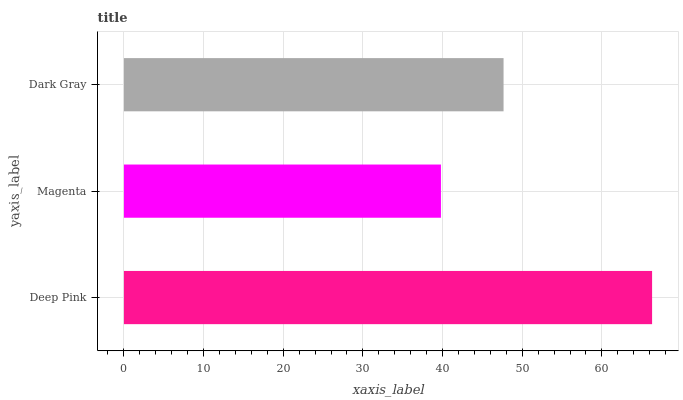Is Magenta the minimum?
Answer yes or no. Yes. Is Deep Pink the maximum?
Answer yes or no. Yes. Is Dark Gray the minimum?
Answer yes or no. No. Is Dark Gray the maximum?
Answer yes or no. No. Is Dark Gray greater than Magenta?
Answer yes or no. Yes. Is Magenta less than Dark Gray?
Answer yes or no. Yes. Is Magenta greater than Dark Gray?
Answer yes or no. No. Is Dark Gray less than Magenta?
Answer yes or no. No. Is Dark Gray the high median?
Answer yes or no. Yes. Is Dark Gray the low median?
Answer yes or no. Yes. Is Magenta the high median?
Answer yes or no. No. Is Magenta the low median?
Answer yes or no. No. 